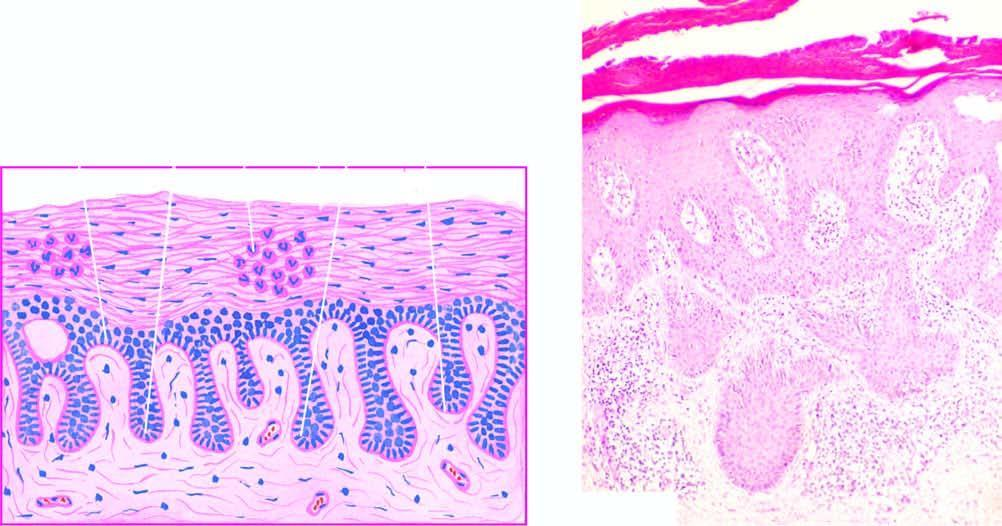what are elongated and oedematous with suprapapillary thinning of epidermis?
Answer the question using a single word or phrase. Papillae 